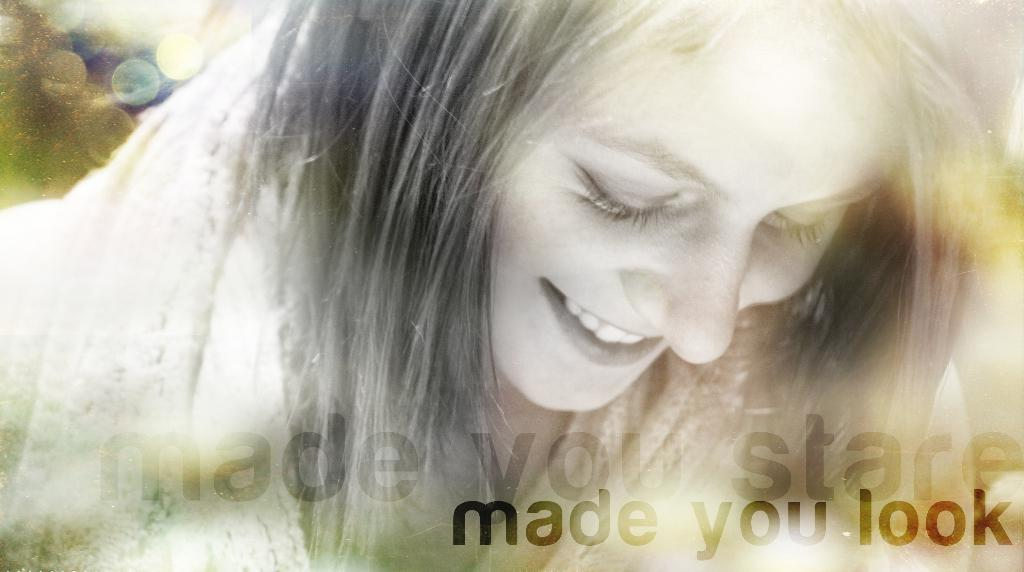Who is present in the image? There is a woman in the image. What is the woman's expression? The woman is smiling. What can be found at the bottom of the image? There is text at the bottom of the image. How would you describe the background of the image? The background of the image is blurred. What type of doctor is present in the wilderness in the image? There is no doctor or wilderness present in the image; it features a woman with a blurred background. 